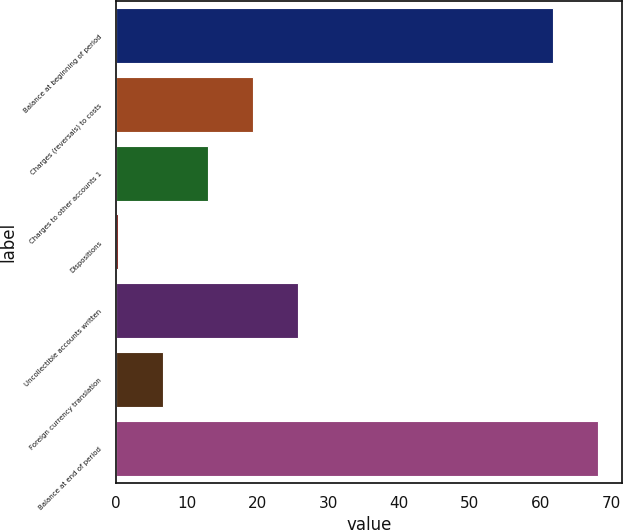Convert chart to OTSL. <chart><loc_0><loc_0><loc_500><loc_500><bar_chart><fcel>Balance at beginning of period<fcel>Charges (reversals) to costs<fcel>Charges to other accounts 1<fcel>Dispositions<fcel>Uncollectible accounts written<fcel>Foreign currency translation<fcel>Balance at end of period<nl><fcel>61.8<fcel>19.31<fcel>12.94<fcel>0.2<fcel>25.68<fcel>6.57<fcel>68.17<nl></chart> 